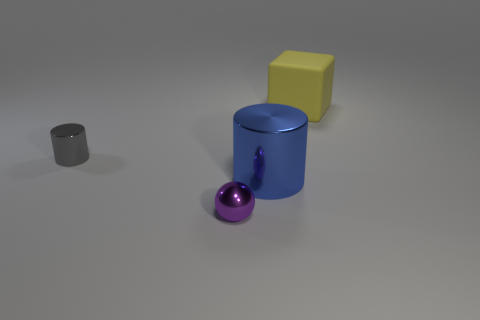Add 4 matte cubes. How many objects exist? 8 Subtract all blocks. How many objects are left? 3 Subtract all red cylinders. Subtract all shiny balls. How many objects are left? 3 Add 2 yellow rubber blocks. How many yellow rubber blocks are left? 3 Add 1 red cubes. How many red cubes exist? 1 Subtract 0 gray blocks. How many objects are left? 4 